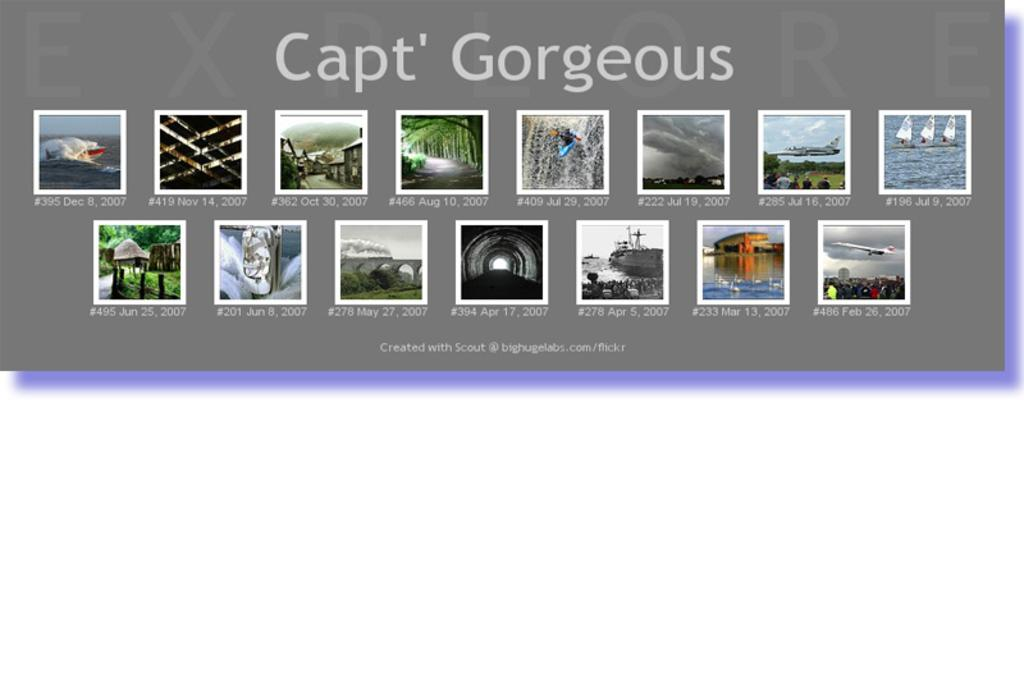What can be seen on the display screen in the image? There are images and text present on the display screen. Can you describe the images on the display screen? Unfortunately, the specific images cannot be described without more information. What type of information might be conveyed by the text on the display screen? The text on the display screen could convey various types of information, such as instructions, messages, or data. How many fangs can be seen on the display screen in the image? There are no fangs present on the display screen in the image. What type of cream is being used to draw the curve on the display screen? There is no curve or cream present on the display screen in the image. 